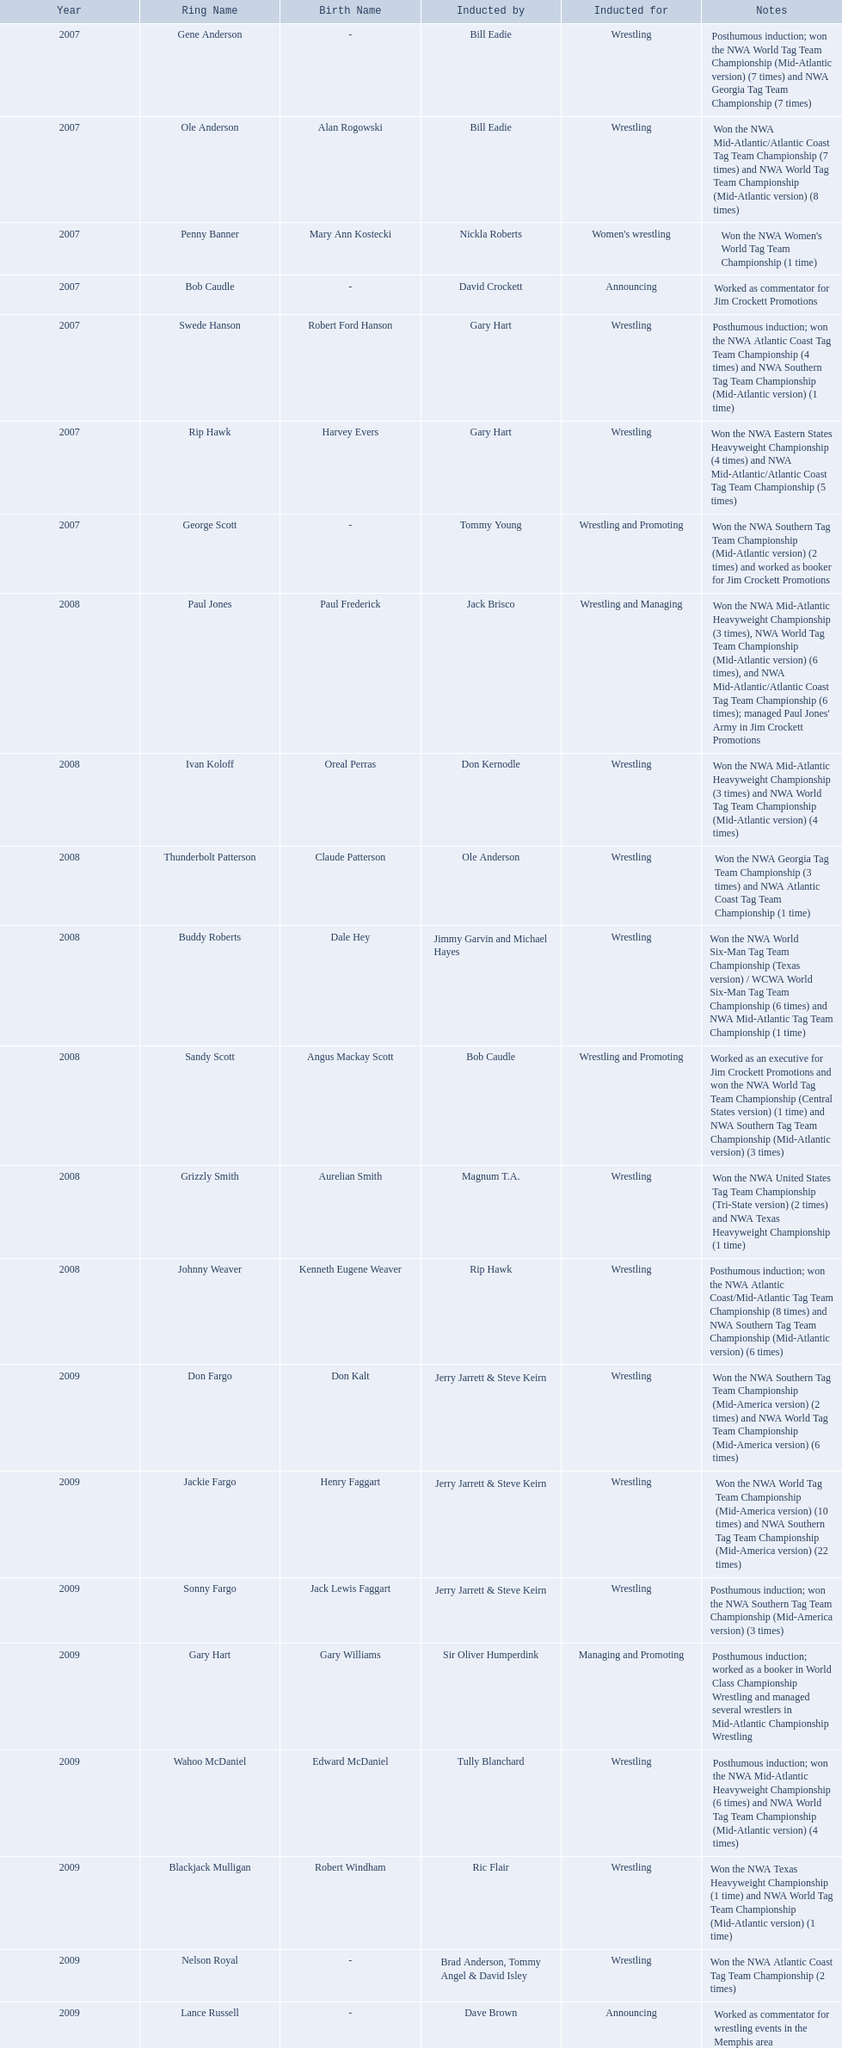What year was the induction held? 2007. Which inductee was not alive? Gene Anderson. What were all the wrestler's ring names? Gene Anderson, Ole Anderson\n(Alan Rogowski), Penny Banner\n(Mary Ann Kostecki), Bob Caudle, Swede Hanson\n(Robert Ford Hanson), Rip Hawk\n(Harvey Evers), George Scott, Paul Jones\n(Paul Frederick), Ivan Koloff\n(Oreal Perras), Thunderbolt Patterson\n(Claude Patterson), Buddy Roberts\n(Dale Hey), Sandy Scott\n(Angus Mackay Scott), Grizzly Smith\n(Aurelian Smith), Johnny Weaver\n(Kenneth Eugene Weaver), Don Fargo\n(Don Kalt), Jackie Fargo\n(Henry Faggart), Sonny Fargo\n(Jack Lewis Faggart), Gary Hart\n(Gary Williams), Wahoo McDaniel\n(Edward McDaniel), Blackjack Mulligan\n(Robert Windham), Nelson Royal, Lance Russell. Besides bob caudle, who was an announcer? Lance Russell. 